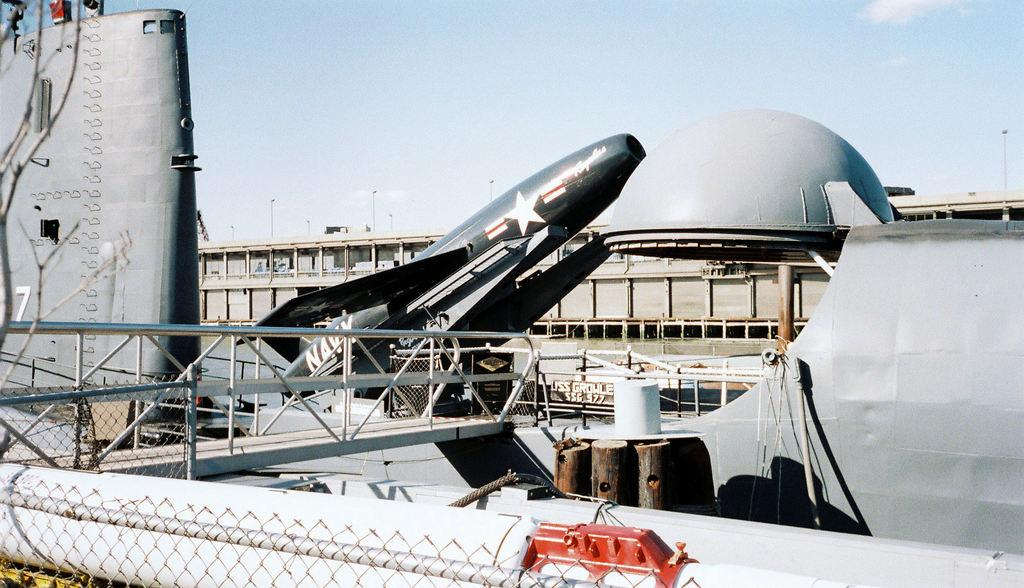What is the main subject of the image? The main subject of the image is a ship. What other objects can be seen in the image? There is a fence, a mesh, a rope, a plane, and metal objects visible in the image. What is in the background of the image? There is a building, poles, and the sky visible in the background of the image. What type of discussion is taking place on the ship in the image? There is no discussion taking place on the ship in the image; it is a still image. In which direction is the ship heading in the image, north or south? The image does not provide information about the direction the ship is heading. 